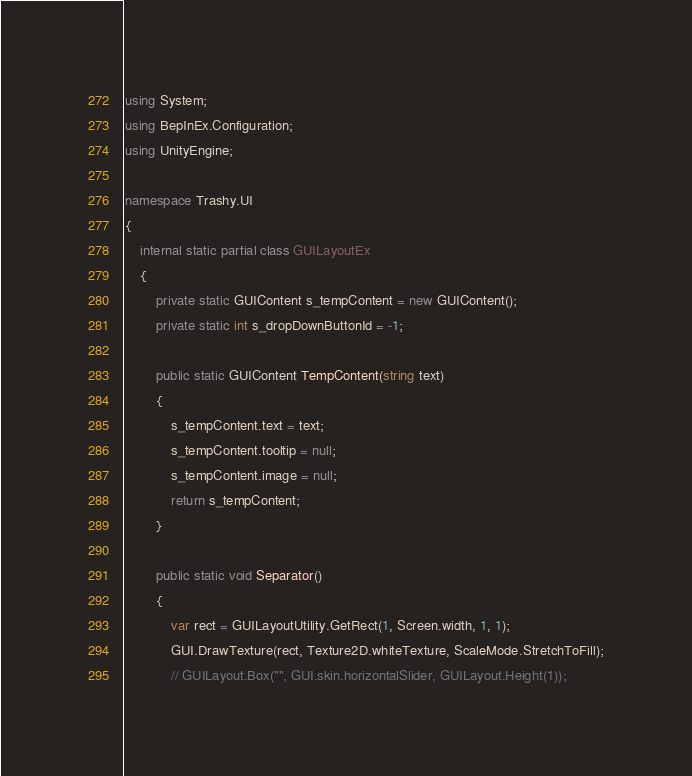<code> <loc_0><loc_0><loc_500><loc_500><_C#_>using System;
using BepInEx.Configuration;
using UnityEngine;

namespace Trashy.UI
{
    internal static partial class GUILayoutEx
    {
        private static GUIContent s_tempContent = new GUIContent();
        private static int s_dropDownButtonId = -1;

        public static GUIContent TempContent(string text)
        {
            s_tempContent.text = text;
            s_tempContent.tooltip = null;
            s_tempContent.image = null;
            return s_tempContent;
        }

        public static void Separator()
        {
            var rect = GUILayoutUtility.GetRect(1, Screen.width, 1, 1);
            GUI.DrawTexture(rect, Texture2D.whiteTexture, ScaleMode.StretchToFill);
            // GUILayout.Box("", GUI.skin.horizontalSlider, GUILayout.Height(1));</code> 